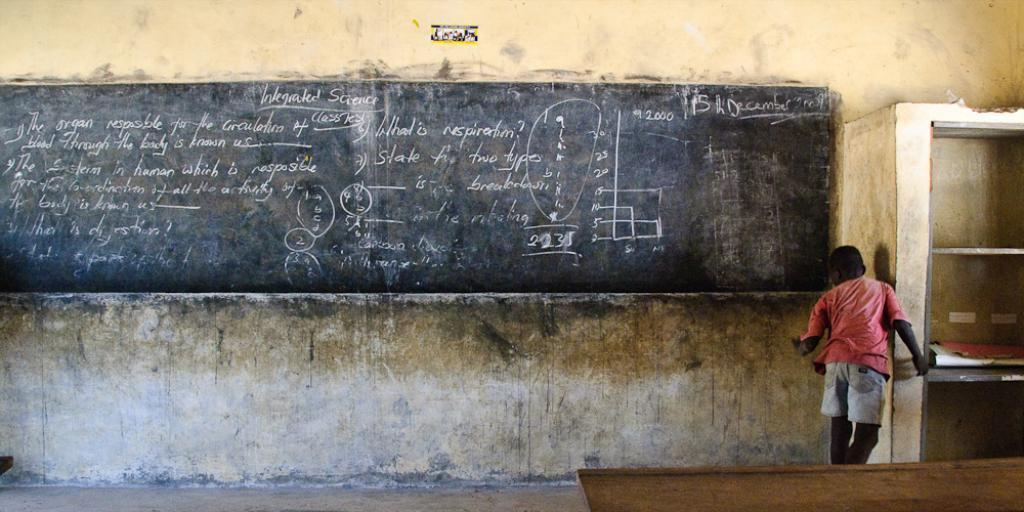What is present in the image? There is a person in the image. What is the person wearing? The person is wearing a red shirt and white shorts. What can be seen in the background of the image? There is a black color board in the background. How is the black color board positioned in the image? The black color board is attached to the wall. What is the color of the wall? The wall is in cream color. Can you tell me how many geese are present in the image? There are no geese present in the image; it features a person wearing a red shirt and white shorts, with a black color board in the background attached to a cream-colored wall. 